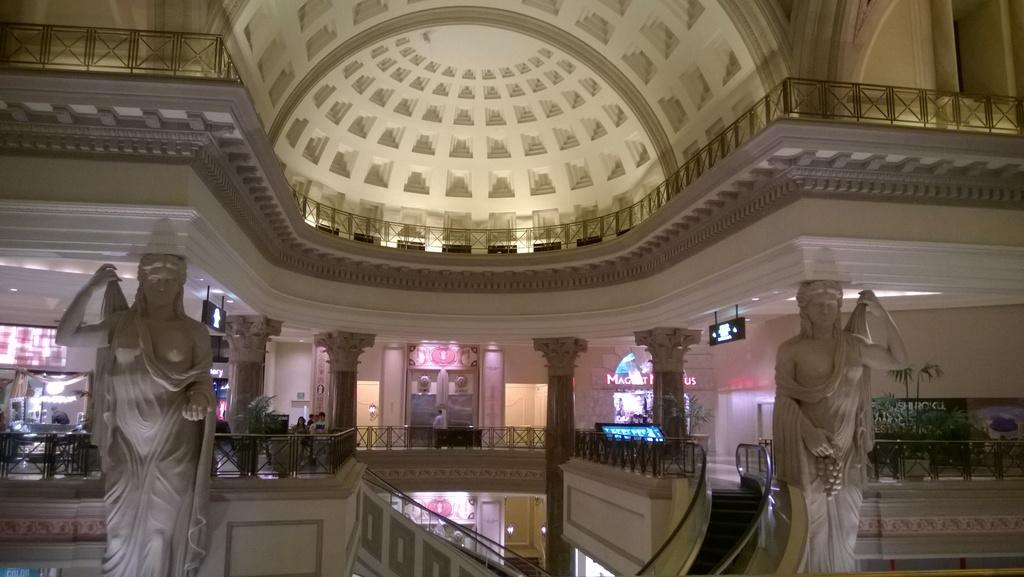What type of art is present in the image? There are sculptures in the image. What color are the sculptures? The sculptures are white in color. What architectural features can be seen in the background of the image? There are pillars, stairs, and boards in the background of the image. What type of joke is being told by the rat in the image? There is no rat present in the image, and therefore no joke is being told. How many pages are visible in the image? There are no pages visible in the image. 